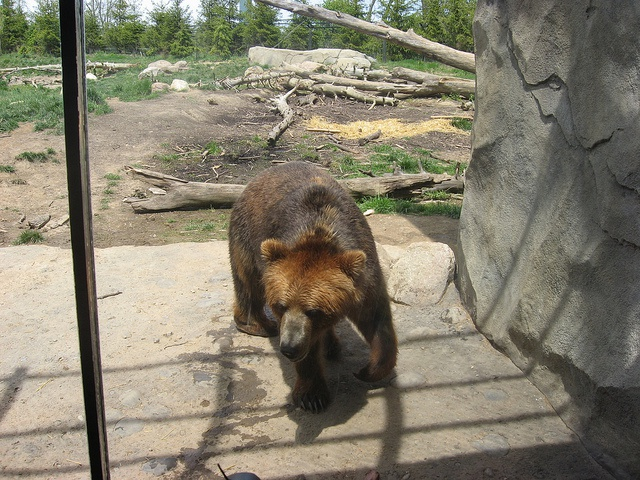Describe the objects in this image and their specific colors. I can see a bear in lightblue, black, gray, and maroon tones in this image. 